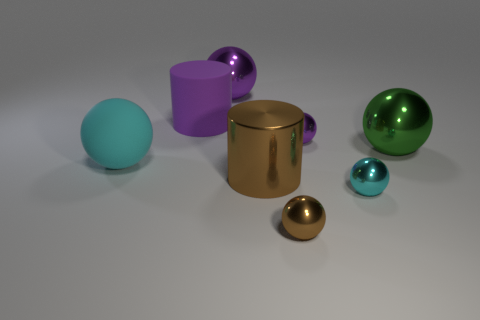Subtract all large green spheres. How many spheres are left? 5 Subtract 0 blue blocks. How many objects are left? 8 Subtract all cylinders. How many objects are left? 6 Subtract 1 balls. How many balls are left? 5 Subtract all cyan cylinders. Subtract all blue balls. How many cylinders are left? 2 Subtract all green spheres. How many red cylinders are left? 0 Subtract all large metal balls. Subtract all metallic balls. How many objects are left? 1 Add 3 purple cylinders. How many purple cylinders are left? 4 Add 2 large blue matte balls. How many large blue matte balls exist? 2 Add 1 cyan metal spheres. How many objects exist? 9 